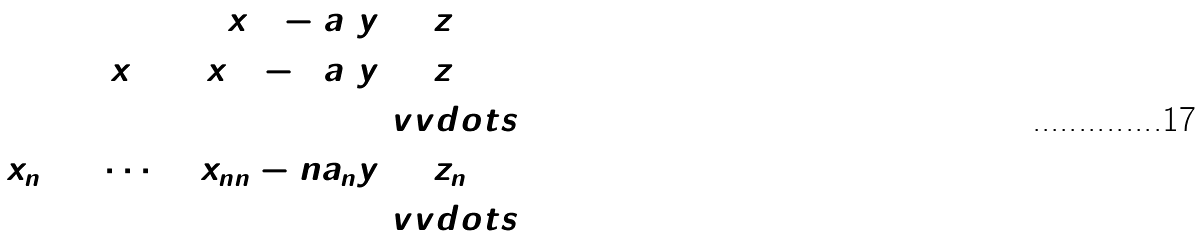<formula> <loc_0><loc_0><loc_500><loc_500>\tilde { x } _ { 1 1 } - a _ { 1 } y & = z _ { 1 } \\ \tilde { x } _ { 2 1 } + \tilde { x } _ { 2 2 } - 2 a _ { 2 } y & = z _ { 2 } \\ & \ v v d o t s { = } \\ \tilde { x } _ { n 1 } + \cdots + \tilde { x } _ { n n } - n a _ { n } y & = z _ { n } \\ & \ v v d o t s { = }</formula> 